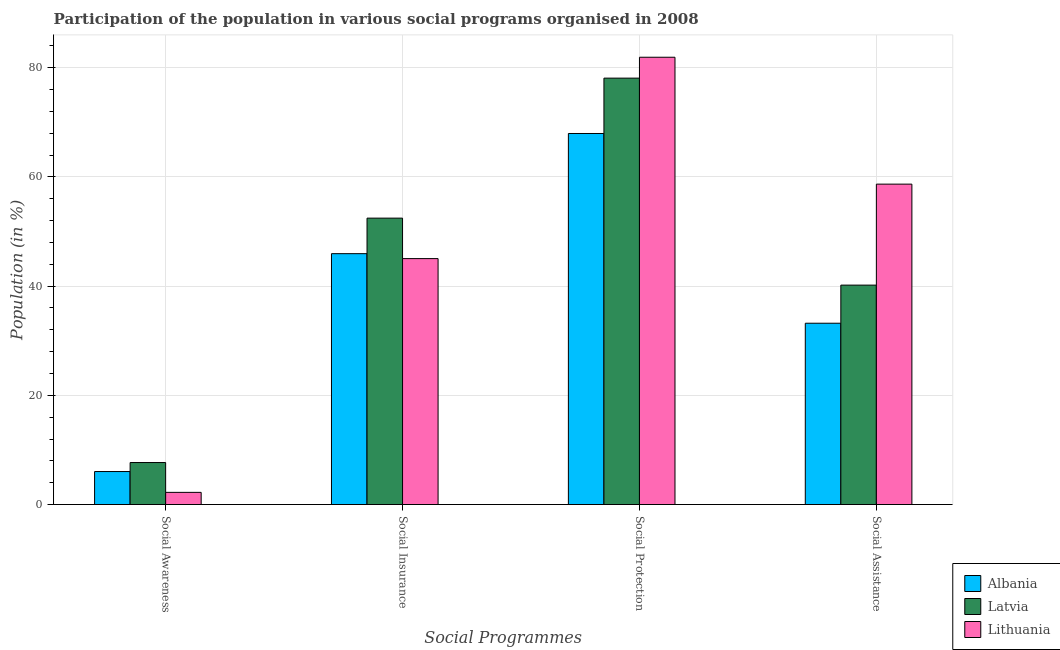How many different coloured bars are there?
Offer a very short reply. 3. How many groups of bars are there?
Provide a short and direct response. 4. How many bars are there on the 3rd tick from the right?
Your response must be concise. 3. What is the label of the 1st group of bars from the left?
Your response must be concise. Social Awareness. What is the participation of population in social protection programs in Latvia?
Your response must be concise. 78.08. Across all countries, what is the maximum participation of population in social assistance programs?
Provide a short and direct response. 58.67. Across all countries, what is the minimum participation of population in social awareness programs?
Offer a terse response. 2.23. In which country was the participation of population in social assistance programs maximum?
Ensure brevity in your answer.  Lithuania. In which country was the participation of population in social awareness programs minimum?
Provide a short and direct response. Lithuania. What is the total participation of population in social awareness programs in the graph?
Keep it short and to the point. 15.96. What is the difference between the participation of population in social assistance programs in Albania and that in Lithuania?
Keep it short and to the point. -25.47. What is the difference between the participation of population in social insurance programs in Albania and the participation of population in social assistance programs in Latvia?
Give a very brief answer. 5.76. What is the average participation of population in social assistance programs per country?
Provide a short and direct response. 44.02. What is the difference between the participation of population in social awareness programs and participation of population in social protection programs in Lithuania?
Keep it short and to the point. -79.68. What is the ratio of the participation of population in social awareness programs in Albania to that in Latvia?
Your answer should be very brief. 0.79. What is the difference between the highest and the second highest participation of population in social insurance programs?
Ensure brevity in your answer.  6.5. What is the difference between the highest and the lowest participation of population in social assistance programs?
Make the answer very short. 25.47. In how many countries, is the participation of population in social assistance programs greater than the average participation of population in social assistance programs taken over all countries?
Provide a short and direct response. 1. Is the sum of the participation of population in social insurance programs in Albania and Latvia greater than the maximum participation of population in social assistance programs across all countries?
Provide a short and direct response. Yes. Is it the case that in every country, the sum of the participation of population in social insurance programs and participation of population in social awareness programs is greater than the sum of participation of population in social protection programs and participation of population in social assistance programs?
Keep it short and to the point. No. What does the 2nd bar from the left in Social Insurance represents?
Ensure brevity in your answer.  Latvia. What does the 3rd bar from the right in Social Awareness represents?
Provide a short and direct response. Albania. Is it the case that in every country, the sum of the participation of population in social awareness programs and participation of population in social insurance programs is greater than the participation of population in social protection programs?
Provide a short and direct response. No. How many bars are there?
Offer a very short reply. 12. How many countries are there in the graph?
Ensure brevity in your answer.  3. Are the values on the major ticks of Y-axis written in scientific E-notation?
Your response must be concise. No. Does the graph contain any zero values?
Provide a short and direct response. No. Does the graph contain grids?
Your answer should be compact. Yes. Where does the legend appear in the graph?
Ensure brevity in your answer.  Bottom right. How are the legend labels stacked?
Your response must be concise. Vertical. What is the title of the graph?
Give a very brief answer. Participation of the population in various social programs organised in 2008. Does "Netherlands" appear as one of the legend labels in the graph?
Ensure brevity in your answer.  No. What is the label or title of the X-axis?
Offer a terse response. Social Programmes. What is the label or title of the Y-axis?
Make the answer very short. Population (in %). What is the Population (in %) in Albania in Social Awareness?
Offer a very short reply. 6.04. What is the Population (in %) of Latvia in Social Awareness?
Provide a short and direct response. 7.69. What is the Population (in %) of Lithuania in Social Awareness?
Give a very brief answer. 2.23. What is the Population (in %) in Albania in Social Insurance?
Give a very brief answer. 45.94. What is the Population (in %) in Latvia in Social Insurance?
Your response must be concise. 52.44. What is the Population (in %) in Lithuania in Social Insurance?
Keep it short and to the point. 45.04. What is the Population (in %) in Albania in Social Protection?
Offer a very short reply. 67.94. What is the Population (in %) in Latvia in Social Protection?
Provide a short and direct response. 78.08. What is the Population (in %) of Lithuania in Social Protection?
Your answer should be compact. 81.91. What is the Population (in %) of Albania in Social Assistance?
Your answer should be very brief. 33.2. What is the Population (in %) in Latvia in Social Assistance?
Your response must be concise. 40.18. What is the Population (in %) in Lithuania in Social Assistance?
Your response must be concise. 58.67. Across all Social Programmes, what is the maximum Population (in %) of Albania?
Provide a short and direct response. 67.94. Across all Social Programmes, what is the maximum Population (in %) of Latvia?
Your answer should be very brief. 78.08. Across all Social Programmes, what is the maximum Population (in %) in Lithuania?
Keep it short and to the point. 81.91. Across all Social Programmes, what is the minimum Population (in %) in Albania?
Your answer should be very brief. 6.04. Across all Social Programmes, what is the minimum Population (in %) of Latvia?
Make the answer very short. 7.69. Across all Social Programmes, what is the minimum Population (in %) in Lithuania?
Offer a terse response. 2.23. What is the total Population (in %) in Albania in the graph?
Offer a very short reply. 153.12. What is the total Population (in %) of Latvia in the graph?
Your answer should be very brief. 178.4. What is the total Population (in %) of Lithuania in the graph?
Offer a very short reply. 187.84. What is the difference between the Population (in %) of Albania in Social Awareness and that in Social Insurance?
Give a very brief answer. -39.9. What is the difference between the Population (in %) of Latvia in Social Awareness and that in Social Insurance?
Your response must be concise. -44.75. What is the difference between the Population (in %) in Lithuania in Social Awareness and that in Social Insurance?
Offer a very short reply. -42.81. What is the difference between the Population (in %) in Albania in Social Awareness and that in Social Protection?
Your response must be concise. -61.9. What is the difference between the Population (in %) in Latvia in Social Awareness and that in Social Protection?
Give a very brief answer. -70.39. What is the difference between the Population (in %) in Lithuania in Social Awareness and that in Social Protection?
Your answer should be compact. -79.68. What is the difference between the Population (in %) in Albania in Social Awareness and that in Social Assistance?
Make the answer very short. -27.16. What is the difference between the Population (in %) in Latvia in Social Awareness and that in Social Assistance?
Give a very brief answer. -32.49. What is the difference between the Population (in %) in Lithuania in Social Awareness and that in Social Assistance?
Your answer should be very brief. -56.44. What is the difference between the Population (in %) in Albania in Social Insurance and that in Social Protection?
Make the answer very short. -22. What is the difference between the Population (in %) in Latvia in Social Insurance and that in Social Protection?
Ensure brevity in your answer.  -25.64. What is the difference between the Population (in %) of Lithuania in Social Insurance and that in Social Protection?
Offer a terse response. -36.87. What is the difference between the Population (in %) in Albania in Social Insurance and that in Social Assistance?
Your response must be concise. 12.74. What is the difference between the Population (in %) in Latvia in Social Insurance and that in Social Assistance?
Your answer should be compact. 12.26. What is the difference between the Population (in %) in Lithuania in Social Insurance and that in Social Assistance?
Make the answer very short. -13.64. What is the difference between the Population (in %) in Albania in Social Protection and that in Social Assistance?
Offer a terse response. 34.74. What is the difference between the Population (in %) in Latvia in Social Protection and that in Social Assistance?
Your answer should be compact. 37.9. What is the difference between the Population (in %) in Lithuania in Social Protection and that in Social Assistance?
Offer a very short reply. 23.23. What is the difference between the Population (in %) of Albania in Social Awareness and the Population (in %) of Latvia in Social Insurance?
Make the answer very short. -46.4. What is the difference between the Population (in %) in Albania in Social Awareness and the Population (in %) in Lithuania in Social Insurance?
Ensure brevity in your answer.  -38.99. What is the difference between the Population (in %) of Latvia in Social Awareness and the Population (in %) of Lithuania in Social Insurance?
Ensure brevity in your answer.  -37.34. What is the difference between the Population (in %) of Albania in Social Awareness and the Population (in %) of Latvia in Social Protection?
Provide a succinct answer. -72.04. What is the difference between the Population (in %) in Albania in Social Awareness and the Population (in %) in Lithuania in Social Protection?
Offer a very short reply. -75.86. What is the difference between the Population (in %) of Latvia in Social Awareness and the Population (in %) of Lithuania in Social Protection?
Your answer should be very brief. -74.21. What is the difference between the Population (in %) in Albania in Social Awareness and the Population (in %) in Latvia in Social Assistance?
Give a very brief answer. -34.14. What is the difference between the Population (in %) of Albania in Social Awareness and the Population (in %) of Lithuania in Social Assistance?
Offer a terse response. -52.63. What is the difference between the Population (in %) of Latvia in Social Awareness and the Population (in %) of Lithuania in Social Assistance?
Make the answer very short. -50.98. What is the difference between the Population (in %) in Albania in Social Insurance and the Population (in %) in Latvia in Social Protection?
Your response must be concise. -32.14. What is the difference between the Population (in %) of Albania in Social Insurance and the Population (in %) of Lithuania in Social Protection?
Make the answer very short. -35.97. What is the difference between the Population (in %) of Latvia in Social Insurance and the Population (in %) of Lithuania in Social Protection?
Offer a terse response. -29.46. What is the difference between the Population (in %) in Albania in Social Insurance and the Population (in %) in Latvia in Social Assistance?
Your answer should be compact. 5.76. What is the difference between the Population (in %) in Albania in Social Insurance and the Population (in %) in Lithuania in Social Assistance?
Keep it short and to the point. -12.73. What is the difference between the Population (in %) in Latvia in Social Insurance and the Population (in %) in Lithuania in Social Assistance?
Offer a terse response. -6.23. What is the difference between the Population (in %) in Albania in Social Protection and the Population (in %) in Latvia in Social Assistance?
Your response must be concise. 27.76. What is the difference between the Population (in %) in Albania in Social Protection and the Population (in %) in Lithuania in Social Assistance?
Make the answer very short. 9.27. What is the difference between the Population (in %) in Latvia in Social Protection and the Population (in %) in Lithuania in Social Assistance?
Your response must be concise. 19.41. What is the average Population (in %) of Albania per Social Programmes?
Keep it short and to the point. 38.28. What is the average Population (in %) in Latvia per Social Programmes?
Provide a succinct answer. 44.6. What is the average Population (in %) in Lithuania per Social Programmes?
Your answer should be compact. 46.96. What is the difference between the Population (in %) of Albania and Population (in %) of Latvia in Social Awareness?
Your response must be concise. -1.65. What is the difference between the Population (in %) in Albania and Population (in %) in Lithuania in Social Awareness?
Provide a succinct answer. 3.81. What is the difference between the Population (in %) of Latvia and Population (in %) of Lithuania in Social Awareness?
Your response must be concise. 5.46. What is the difference between the Population (in %) in Albania and Population (in %) in Latvia in Social Insurance?
Your response must be concise. -6.5. What is the difference between the Population (in %) in Albania and Population (in %) in Lithuania in Social Insurance?
Ensure brevity in your answer.  0.9. What is the difference between the Population (in %) in Latvia and Population (in %) in Lithuania in Social Insurance?
Your response must be concise. 7.41. What is the difference between the Population (in %) in Albania and Population (in %) in Latvia in Social Protection?
Your answer should be compact. -10.14. What is the difference between the Population (in %) of Albania and Population (in %) of Lithuania in Social Protection?
Your answer should be compact. -13.96. What is the difference between the Population (in %) of Latvia and Population (in %) of Lithuania in Social Protection?
Keep it short and to the point. -3.82. What is the difference between the Population (in %) of Albania and Population (in %) of Latvia in Social Assistance?
Provide a succinct answer. -6.98. What is the difference between the Population (in %) of Albania and Population (in %) of Lithuania in Social Assistance?
Keep it short and to the point. -25.47. What is the difference between the Population (in %) in Latvia and Population (in %) in Lithuania in Social Assistance?
Offer a very short reply. -18.49. What is the ratio of the Population (in %) of Albania in Social Awareness to that in Social Insurance?
Your answer should be compact. 0.13. What is the ratio of the Population (in %) of Latvia in Social Awareness to that in Social Insurance?
Your response must be concise. 0.15. What is the ratio of the Population (in %) of Lithuania in Social Awareness to that in Social Insurance?
Ensure brevity in your answer.  0.05. What is the ratio of the Population (in %) in Albania in Social Awareness to that in Social Protection?
Keep it short and to the point. 0.09. What is the ratio of the Population (in %) in Latvia in Social Awareness to that in Social Protection?
Offer a very short reply. 0.1. What is the ratio of the Population (in %) of Lithuania in Social Awareness to that in Social Protection?
Provide a succinct answer. 0.03. What is the ratio of the Population (in %) of Albania in Social Awareness to that in Social Assistance?
Make the answer very short. 0.18. What is the ratio of the Population (in %) of Latvia in Social Awareness to that in Social Assistance?
Give a very brief answer. 0.19. What is the ratio of the Population (in %) in Lithuania in Social Awareness to that in Social Assistance?
Your answer should be compact. 0.04. What is the ratio of the Population (in %) of Albania in Social Insurance to that in Social Protection?
Give a very brief answer. 0.68. What is the ratio of the Population (in %) in Latvia in Social Insurance to that in Social Protection?
Your answer should be compact. 0.67. What is the ratio of the Population (in %) of Lithuania in Social Insurance to that in Social Protection?
Provide a succinct answer. 0.55. What is the ratio of the Population (in %) in Albania in Social Insurance to that in Social Assistance?
Your answer should be compact. 1.38. What is the ratio of the Population (in %) in Latvia in Social Insurance to that in Social Assistance?
Ensure brevity in your answer.  1.31. What is the ratio of the Population (in %) of Lithuania in Social Insurance to that in Social Assistance?
Give a very brief answer. 0.77. What is the ratio of the Population (in %) of Albania in Social Protection to that in Social Assistance?
Give a very brief answer. 2.05. What is the ratio of the Population (in %) of Latvia in Social Protection to that in Social Assistance?
Offer a very short reply. 1.94. What is the ratio of the Population (in %) of Lithuania in Social Protection to that in Social Assistance?
Make the answer very short. 1.4. What is the difference between the highest and the second highest Population (in %) in Albania?
Make the answer very short. 22. What is the difference between the highest and the second highest Population (in %) in Latvia?
Your answer should be compact. 25.64. What is the difference between the highest and the second highest Population (in %) in Lithuania?
Ensure brevity in your answer.  23.23. What is the difference between the highest and the lowest Population (in %) in Albania?
Give a very brief answer. 61.9. What is the difference between the highest and the lowest Population (in %) in Latvia?
Keep it short and to the point. 70.39. What is the difference between the highest and the lowest Population (in %) in Lithuania?
Offer a very short reply. 79.68. 